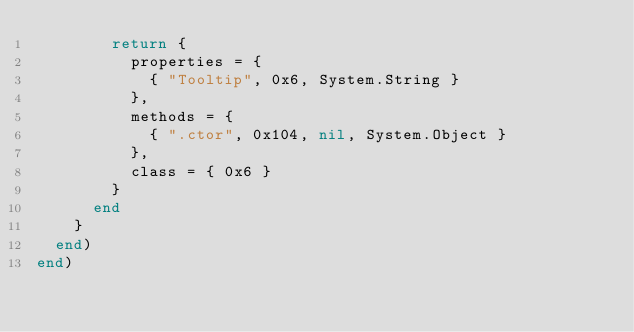Convert code to text. <code><loc_0><loc_0><loc_500><loc_500><_Lua_>        return {
          properties = {
            { "Tooltip", 0x6, System.String }
          },
          methods = {
            { ".ctor", 0x104, nil, System.Object }
          },
          class = { 0x6 }
        }
      end
    }
  end)
end)
</code> 